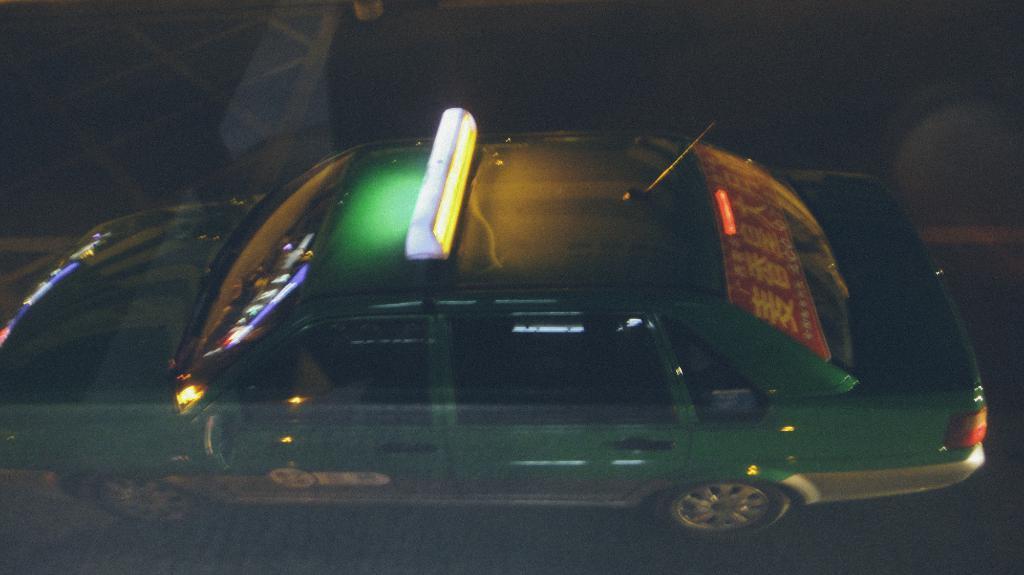Could you give a brief overview of what you see in this image? This picture contains a car, which is moving on the road. This car is in green color. In the background, it is black in color. This picture is clicked in the dark. 